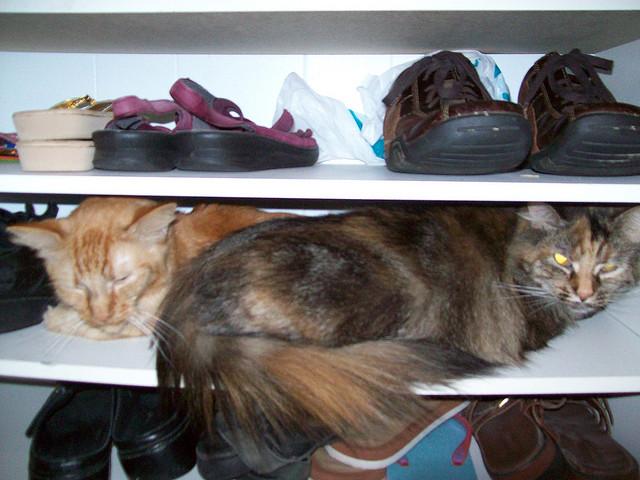Are these cats the same breed?
Quick response, please. No. Do you see any blue tennis shoes?
Write a very short answer. No. Do these cats like shoes?
Keep it brief. Yes. 